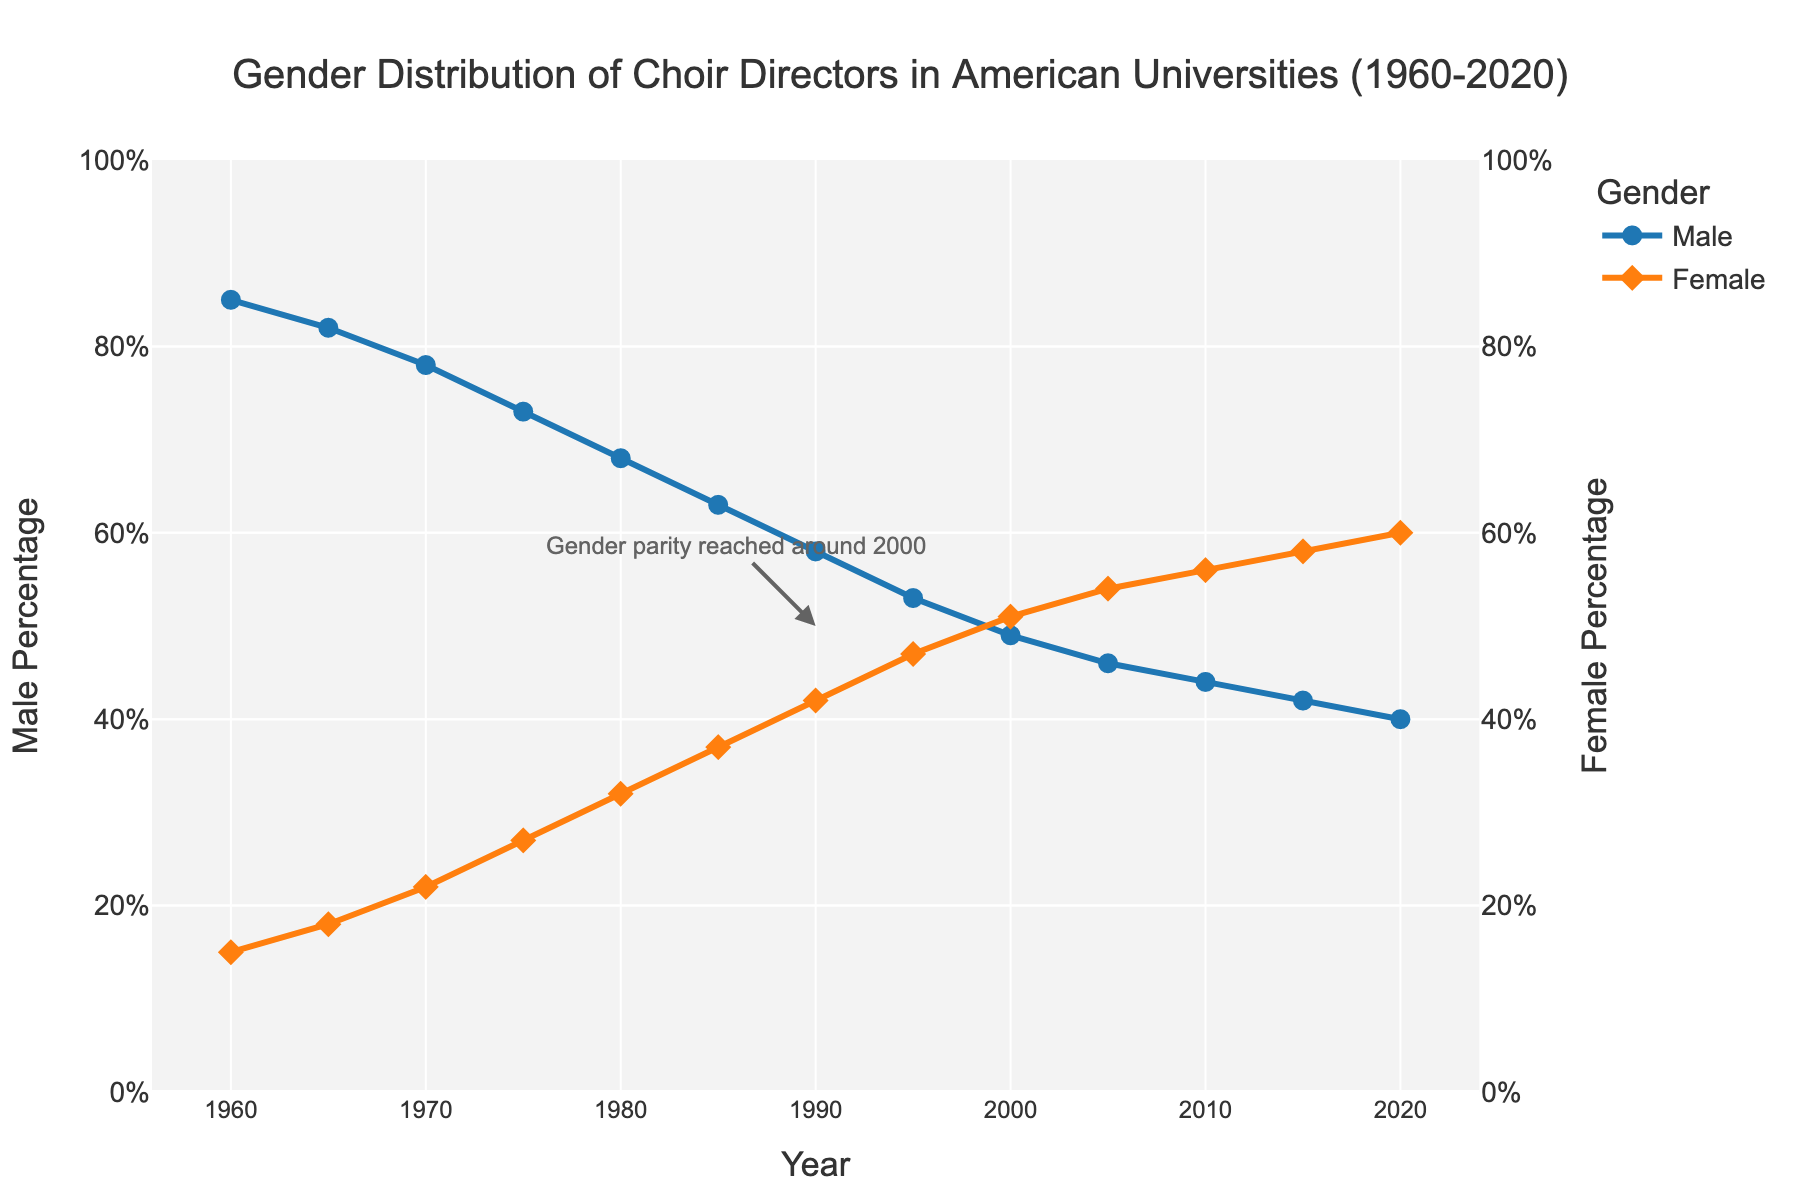What's the male choir director percentage in 1960? Look at the data or chart and find the male percentage for the year 1960. It is shown as 85%.
Answer: 85% What's the combined percentage of male and female choir directors in 1990? In 1990, add the male percentage (58%) and the female percentage (42%). 58% + 42% = 100%.
Answer: 100% In which year did the percentage of female choir directors surpass male directors? Identify the year on the chart where the female percentage first exceeds the male percentage. This happens in 2000, where the female percentage is 51% and the male percentage is 49%.
Answer: 2000 How did the percentage of female choir directors change from 1980 to 1990? Compare the female percentage in 1980 (32%) to the percentage in 1990 (42%). Subtract 32% from 42% to find the change, which is 42% - 32% = 10%.
Answer: Increased by 10% What annotation is shown on the chart and what does it signify? The annotation is "Gender parity reached around 2000". It indicates that around the year 2000, the percentages of male and female choir directors were roughly equal.
Answer: Gender parity reached around 2000 Which gender had a larger percentage change from 1960 to 2020? Calculate the absolute percentage change for both male and female directors. Male: 85% - 40% = 45%. Female: 60% - 15% = 45%. Both have the same percentage change.
Answer: Both equally By how many percentage points did the male choir directors decrease between 1970 and 1985? Find the male percentage in 1970 (78%) and in 1985 (63%). Subtract 63% from 78% to get the decrease: 78% - 63% = 15%.
Answer: 15% What trend is observed in the female choir director percentage from 1960 to 2020? Observe the line representing the female percentage; it shows a consistent increase over time from 15% in 1960 to 60% in 2020.
Answer: Increasing trend Compare the female percentage of choir directors in 2005 to 2020. Look at the female percentages for the years 2005 (54%) and 2020 (60%). 60% is higher than 54%, so the percentage increased.
Answer: Increased What is the male and female percentage ratio in 2015? Find the male percentage (42%) and female percentage (58%) in 2015. The ratio of male to female directors is 42:58. Simplified, it is approximately 21:29.
Answer: Approximately 21:29 